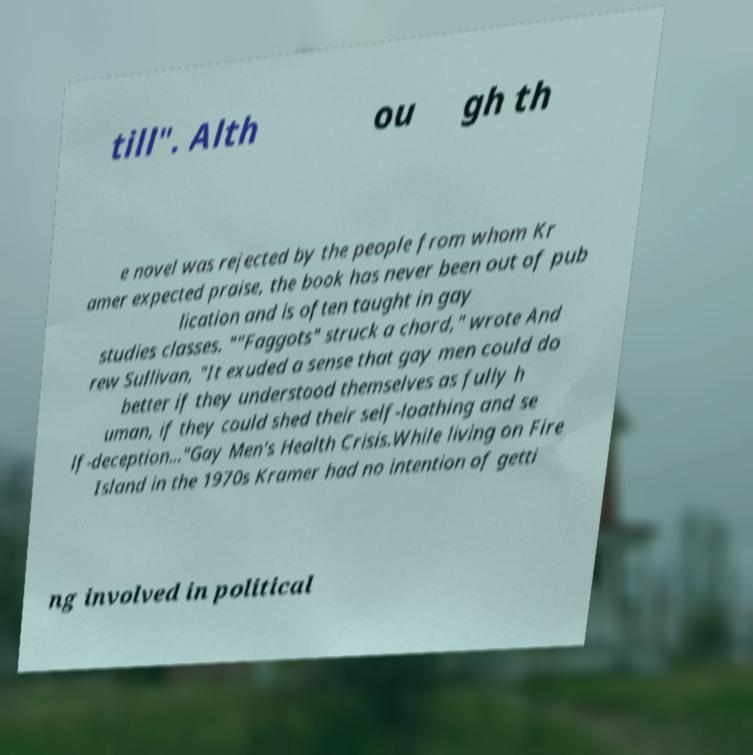For documentation purposes, I need the text within this image transcribed. Could you provide that? till". Alth ou gh th e novel was rejected by the people from whom Kr amer expected praise, the book has never been out of pub lication and is often taught in gay studies classes. ""Faggots" struck a chord," wrote And rew Sullivan, "It exuded a sense that gay men could do better if they understood themselves as fully h uman, if they could shed their self-loathing and se lf-deception..."Gay Men's Health Crisis.While living on Fire Island in the 1970s Kramer had no intention of getti ng involved in political 